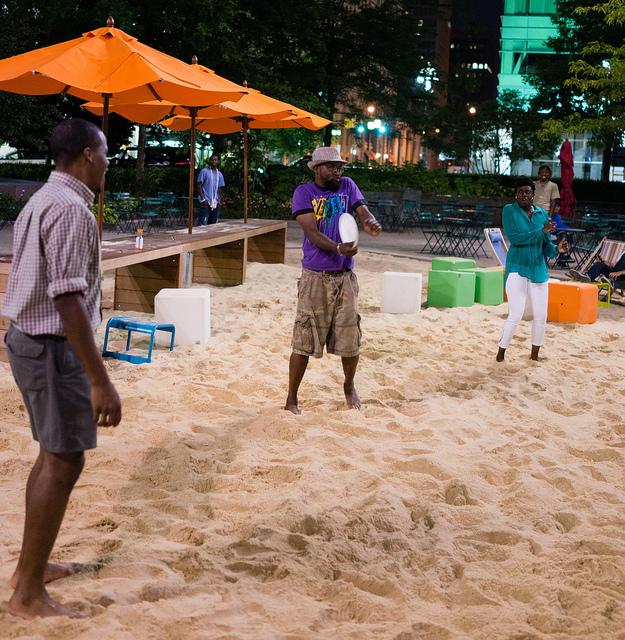Is the man in purple a white man?
Answer briefly. No. What is above the tables behind the people?
Write a very short answer. Umbrellas. How many humans are in the foreground of the picture?
Write a very short answer. 3. 